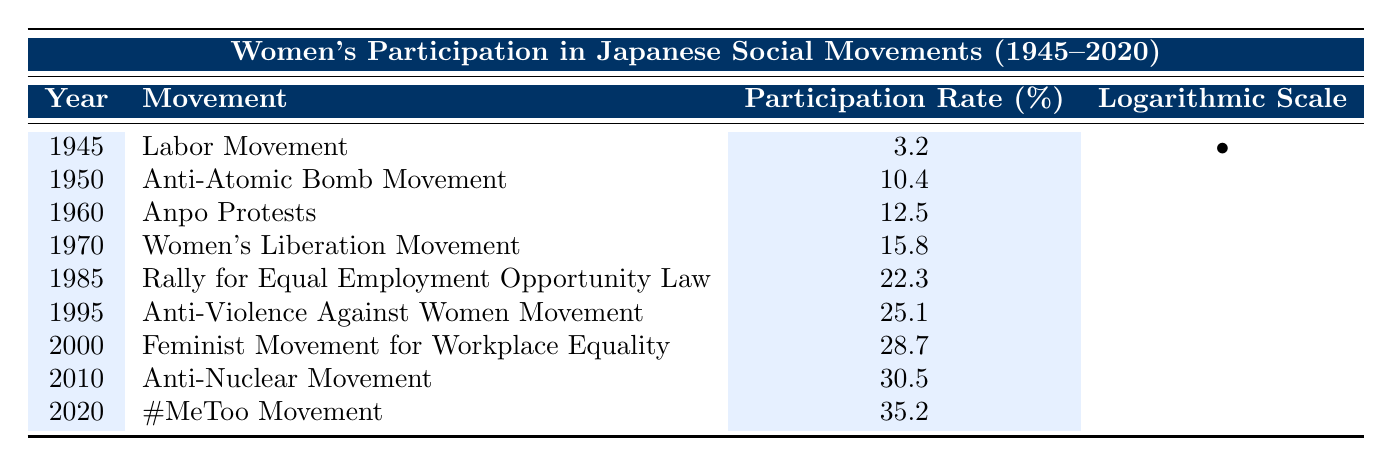What was the women's participation rate in the Labor Movement in 1945? The table shows that in 1945, under the Labor Movement, the women's participation rate was recorded as 3.2%.
Answer: 3.2% In which year did the women's participation rate exceed 25% for the first time? By examining the table, the first year when the participation rate exceeds 25% is 1995 with the Anti-Violence Against Women Movement, where the rate was 25.1%.
Answer: 1995 What is the difference in the women's participation rate between the Women's Liberation Movement in 1970 and the #MeToo Movement in 2020? The participation rate for the Women's Liberation Movement in 1970 is 15.8% and for the #MeToo Movement in 2020, it is 35.2%. The difference is calculated as 35.2 - 15.8 = 19.4%.
Answer: 19.4% Did women's participation in the Anti-Nuclear Movement in 2010 surpass that of the Labor Movement in 1945? According to the table, the participation rate in the Anti-Nuclear Movement in 2010 is 30.5%, which is greater than the 3.2% from the Labor Movement in 1945. Therefore, the statement is true.
Answer: Yes What was the average participation rate of women across all the movements listed in the table? To calculate the average, we sum all the participation rates: (3.2 + 10.4 + 12.5 + 15.8 + 22.3 + 25.1 + 28.7 + 30.5 + 35.2) = 152.3%. There are 9 movements, so the average is 152.3 / 9 = 16.92%.
Answer: 16.92% Which movement had the highest reported women's participation rate and what was that rate? Looking at the table, the #MeToo Movement in 2020 had the highest participation rate of 35.2%.
Answer: #MeToo Movement, 35.2% Was there an increase in women's participation rate from the Anpo Protests in 1960 to the Rally for Equal Employment Opportunity Law in 1985? The Anpo Protests in 1960 recorded 12.5% and the Rally for Equal Employment Opportunity Law in 1985 showed 22.3%. Since 22.3% is greater than 12.5%, there was indeed an increase.
Answer: Yes How many movements had women's participation rates above 30%? Checking the table, there are 3 movements with participation rates above 30%: the Feminist Movement for Workplace Equality in 2000 (28.7%), Anti-Nuclear Movement in 2010 (30.5%), and #MeToo Movement in 2020 (35.2%). Thus, the total is 3.
Answer: 3 